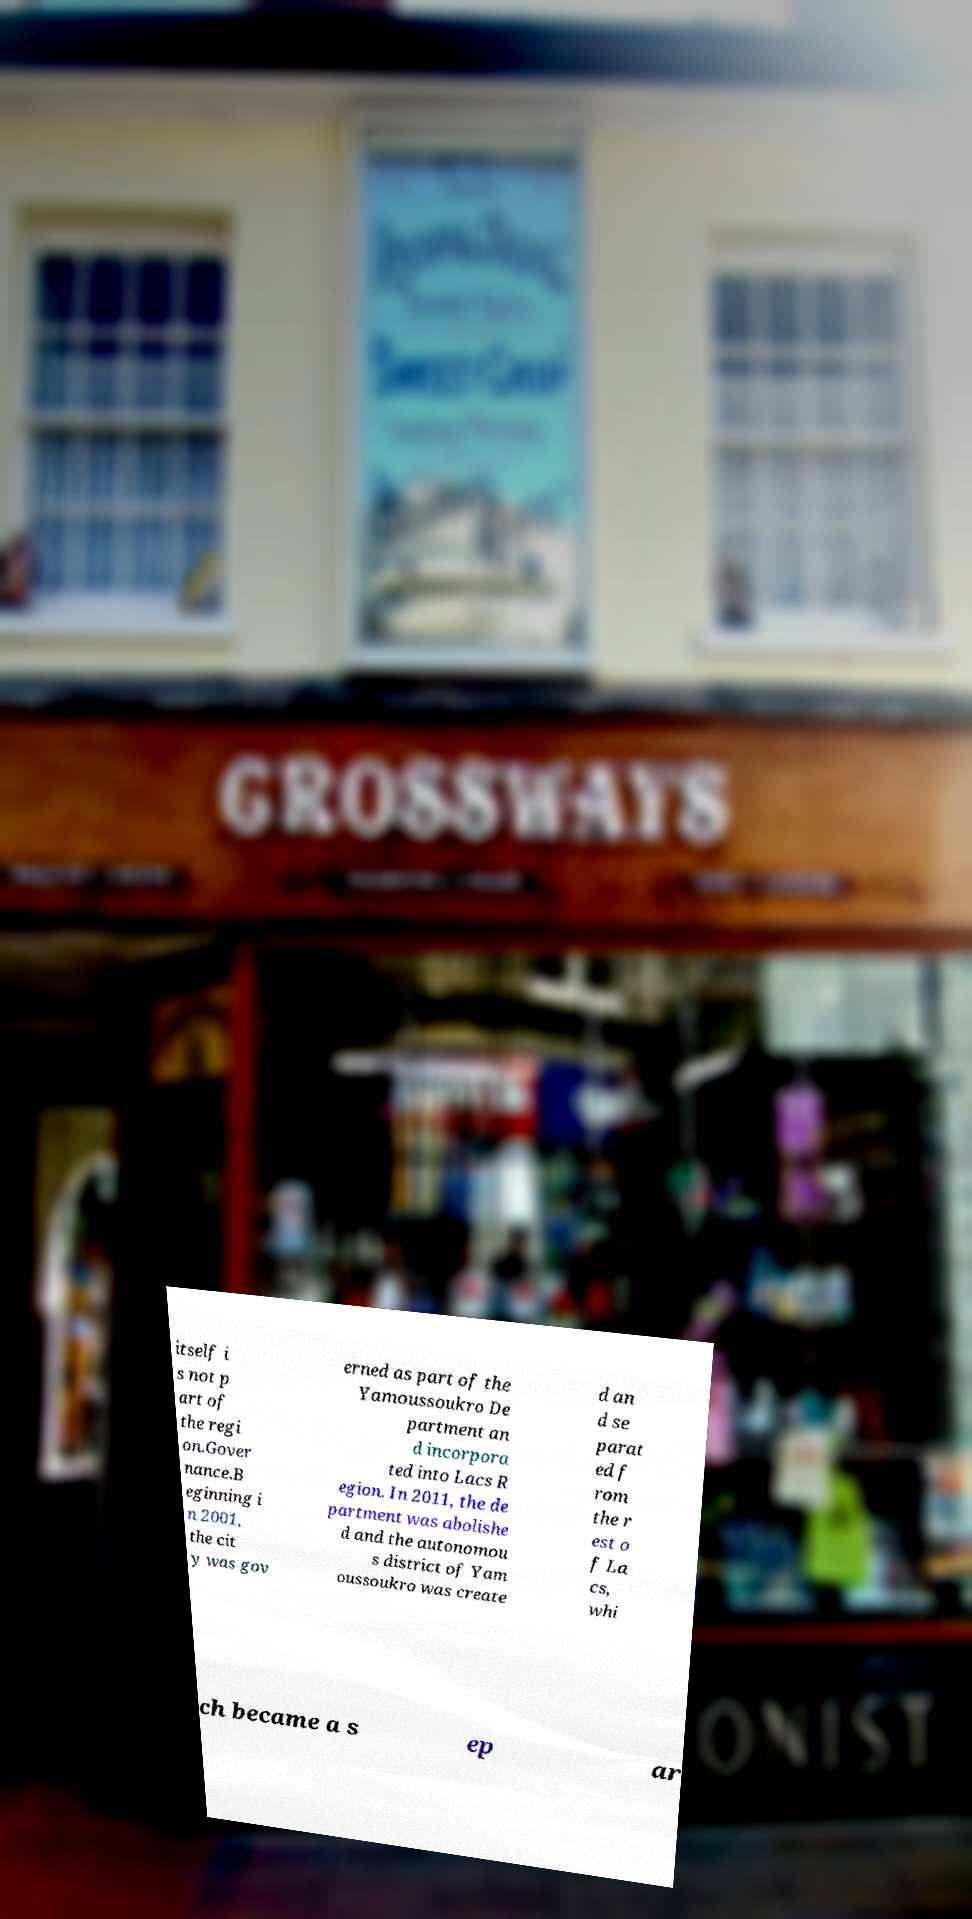There's text embedded in this image that I need extracted. Can you transcribe it verbatim? itself i s not p art of the regi on.Gover nance.B eginning i n 2001, the cit y was gov erned as part of the Yamoussoukro De partment an d incorpora ted into Lacs R egion. In 2011, the de partment was abolishe d and the autonomou s district of Yam oussoukro was create d an d se parat ed f rom the r est o f La cs, whi ch became a s ep ar 